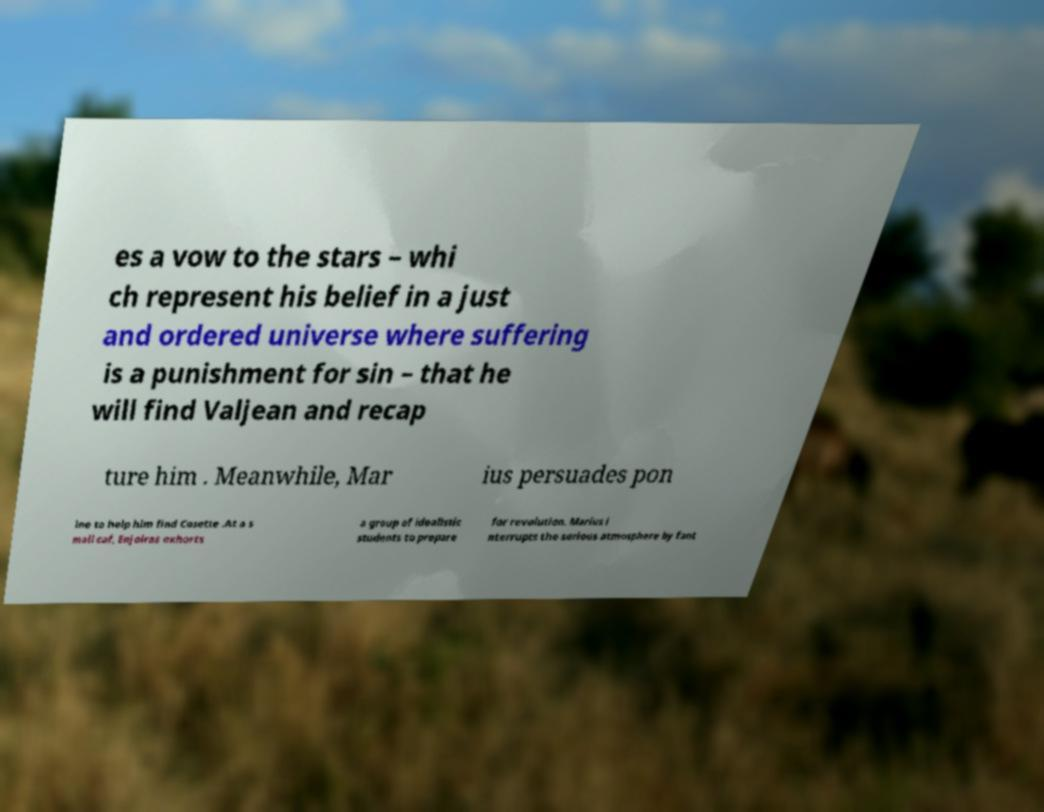Could you assist in decoding the text presented in this image and type it out clearly? es a vow to the stars – whi ch represent his belief in a just and ordered universe where suffering is a punishment for sin – that he will find Valjean and recap ture him . Meanwhile, Mar ius persuades pon ine to help him find Cosette .At a s mall caf, Enjolras exhorts a group of idealistic students to prepare for revolution. Marius i nterrupts the serious atmosphere by fant 